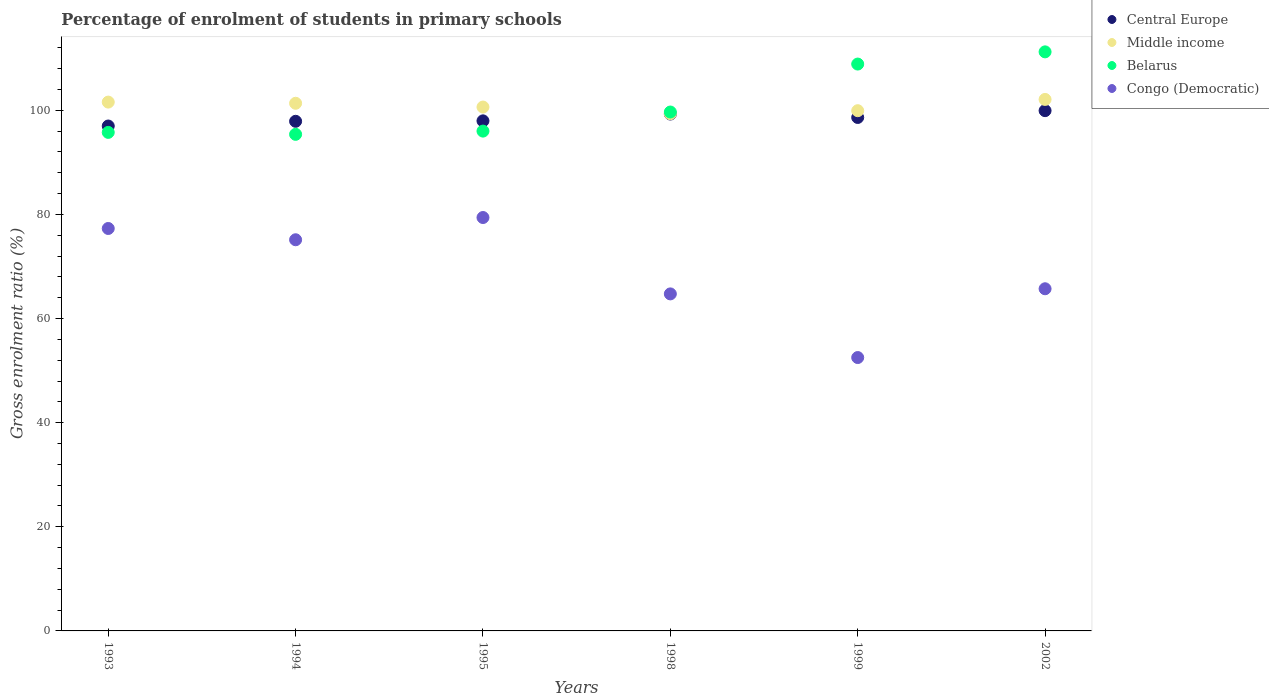Is the number of dotlines equal to the number of legend labels?
Provide a succinct answer. Yes. What is the percentage of students enrolled in primary schools in Central Europe in 1995?
Give a very brief answer. 97.98. Across all years, what is the maximum percentage of students enrolled in primary schools in Belarus?
Provide a short and direct response. 111.23. Across all years, what is the minimum percentage of students enrolled in primary schools in Middle income?
Offer a terse response. 99.35. What is the total percentage of students enrolled in primary schools in Middle income in the graph?
Keep it short and to the point. 604.95. What is the difference between the percentage of students enrolled in primary schools in Congo (Democratic) in 1993 and that in 1998?
Provide a succinct answer. 12.57. What is the difference between the percentage of students enrolled in primary schools in Central Europe in 1998 and the percentage of students enrolled in primary schools in Congo (Democratic) in 2002?
Make the answer very short. 33.56. What is the average percentage of students enrolled in primary schools in Belarus per year?
Your response must be concise. 101.16. In the year 1999, what is the difference between the percentage of students enrolled in primary schools in Belarus and percentage of students enrolled in primary schools in Congo (Democratic)?
Provide a short and direct response. 56.38. In how many years, is the percentage of students enrolled in primary schools in Congo (Democratic) greater than 52 %?
Ensure brevity in your answer.  6. What is the ratio of the percentage of students enrolled in primary schools in Congo (Democratic) in 1993 to that in 1998?
Your response must be concise. 1.19. Is the percentage of students enrolled in primary schools in Congo (Democratic) in 1999 less than that in 2002?
Give a very brief answer. Yes. Is the difference between the percentage of students enrolled in primary schools in Belarus in 1993 and 1999 greater than the difference between the percentage of students enrolled in primary schools in Congo (Democratic) in 1993 and 1999?
Offer a terse response. No. What is the difference between the highest and the second highest percentage of students enrolled in primary schools in Middle income?
Give a very brief answer. 0.51. What is the difference between the highest and the lowest percentage of students enrolled in primary schools in Belarus?
Give a very brief answer. 15.84. Is it the case that in every year, the sum of the percentage of students enrolled in primary schools in Congo (Democratic) and percentage of students enrolled in primary schools in Belarus  is greater than the percentage of students enrolled in primary schools in Central Europe?
Ensure brevity in your answer.  Yes. Does the percentage of students enrolled in primary schools in Middle income monotonically increase over the years?
Offer a very short reply. No. Is the percentage of students enrolled in primary schools in Middle income strictly greater than the percentage of students enrolled in primary schools in Central Europe over the years?
Your answer should be very brief. Yes. Is the percentage of students enrolled in primary schools in Middle income strictly less than the percentage of students enrolled in primary schools in Central Europe over the years?
Your answer should be very brief. No. How many dotlines are there?
Your answer should be very brief. 4. How many years are there in the graph?
Make the answer very short. 6. What is the difference between two consecutive major ticks on the Y-axis?
Your answer should be compact. 20. Are the values on the major ticks of Y-axis written in scientific E-notation?
Provide a short and direct response. No. Does the graph contain any zero values?
Your response must be concise. No. How many legend labels are there?
Your answer should be compact. 4. What is the title of the graph?
Provide a short and direct response. Percentage of enrolment of students in primary schools. Does "Upper middle income" appear as one of the legend labels in the graph?
Offer a very short reply. No. What is the Gross enrolment ratio (%) of Central Europe in 1993?
Your answer should be compact. 96.99. What is the Gross enrolment ratio (%) of Middle income in 1993?
Your answer should be compact. 101.58. What is the Gross enrolment ratio (%) in Belarus in 1993?
Offer a very short reply. 95.77. What is the Gross enrolment ratio (%) in Congo (Democratic) in 1993?
Provide a short and direct response. 77.31. What is the Gross enrolment ratio (%) of Central Europe in 1994?
Provide a short and direct response. 97.9. What is the Gross enrolment ratio (%) of Middle income in 1994?
Give a very brief answer. 101.36. What is the Gross enrolment ratio (%) in Belarus in 1994?
Offer a very short reply. 95.39. What is the Gross enrolment ratio (%) in Congo (Democratic) in 1994?
Provide a short and direct response. 75.14. What is the Gross enrolment ratio (%) in Central Europe in 1995?
Keep it short and to the point. 97.98. What is the Gross enrolment ratio (%) in Middle income in 1995?
Give a very brief answer. 100.63. What is the Gross enrolment ratio (%) of Belarus in 1995?
Your answer should be compact. 96.01. What is the Gross enrolment ratio (%) of Congo (Democratic) in 1995?
Offer a terse response. 79.41. What is the Gross enrolment ratio (%) in Central Europe in 1998?
Offer a terse response. 99.29. What is the Gross enrolment ratio (%) in Middle income in 1998?
Your answer should be very brief. 99.35. What is the Gross enrolment ratio (%) in Belarus in 1998?
Your response must be concise. 99.68. What is the Gross enrolment ratio (%) in Congo (Democratic) in 1998?
Your answer should be very brief. 64.74. What is the Gross enrolment ratio (%) in Central Europe in 1999?
Make the answer very short. 98.63. What is the Gross enrolment ratio (%) of Middle income in 1999?
Your answer should be very brief. 99.93. What is the Gross enrolment ratio (%) in Belarus in 1999?
Provide a short and direct response. 108.89. What is the Gross enrolment ratio (%) of Congo (Democratic) in 1999?
Your response must be concise. 52.51. What is the Gross enrolment ratio (%) in Central Europe in 2002?
Make the answer very short. 99.94. What is the Gross enrolment ratio (%) in Middle income in 2002?
Give a very brief answer. 102.1. What is the Gross enrolment ratio (%) of Belarus in 2002?
Make the answer very short. 111.23. What is the Gross enrolment ratio (%) of Congo (Democratic) in 2002?
Provide a succinct answer. 65.73. Across all years, what is the maximum Gross enrolment ratio (%) in Central Europe?
Provide a succinct answer. 99.94. Across all years, what is the maximum Gross enrolment ratio (%) of Middle income?
Ensure brevity in your answer.  102.1. Across all years, what is the maximum Gross enrolment ratio (%) of Belarus?
Provide a succinct answer. 111.23. Across all years, what is the maximum Gross enrolment ratio (%) of Congo (Democratic)?
Your answer should be very brief. 79.41. Across all years, what is the minimum Gross enrolment ratio (%) in Central Europe?
Your answer should be very brief. 96.99. Across all years, what is the minimum Gross enrolment ratio (%) of Middle income?
Your response must be concise. 99.35. Across all years, what is the minimum Gross enrolment ratio (%) in Belarus?
Provide a short and direct response. 95.39. Across all years, what is the minimum Gross enrolment ratio (%) in Congo (Democratic)?
Your answer should be very brief. 52.51. What is the total Gross enrolment ratio (%) in Central Europe in the graph?
Your answer should be very brief. 590.72. What is the total Gross enrolment ratio (%) in Middle income in the graph?
Keep it short and to the point. 604.95. What is the total Gross enrolment ratio (%) in Belarus in the graph?
Your answer should be very brief. 606.97. What is the total Gross enrolment ratio (%) in Congo (Democratic) in the graph?
Give a very brief answer. 414.83. What is the difference between the Gross enrolment ratio (%) of Central Europe in 1993 and that in 1994?
Offer a very short reply. -0.91. What is the difference between the Gross enrolment ratio (%) of Middle income in 1993 and that in 1994?
Give a very brief answer. 0.23. What is the difference between the Gross enrolment ratio (%) of Belarus in 1993 and that in 1994?
Keep it short and to the point. 0.37. What is the difference between the Gross enrolment ratio (%) in Congo (Democratic) in 1993 and that in 1994?
Make the answer very short. 2.17. What is the difference between the Gross enrolment ratio (%) in Central Europe in 1993 and that in 1995?
Provide a succinct answer. -0.99. What is the difference between the Gross enrolment ratio (%) in Middle income in 1993 and that in 1995?
Give a very brief answer. 0.95. What is the difference between the Gross enrolment ratio (%) of Belarus in 1993 and that in 1995?
Your response must be concise. -0.25. What is the difference between the Gross enrolment ratio (%) in Congo (Democratic) in 1993 and that in 1995?
Ensure brevity in your answer.  -2.11. What is the difference between the Gross enrolment ratio (%) in Central Europe in 1993 and that in 1998?
Keep it short and to the point. -2.3. What is the difference between the Gross enrolment ratio (%) in Middle income in 1993 and that in 1998?
Make the answer very short. 2.23. What is the difference between the Gross enrolment ratio (%) of Belarus in 1993 and that in 1998?
Keep it short and to the point. -3.91. What is the difference between the Gross enrolment ratio (%) of Congo (Democratic) in 1993 and that in 1998?
Make the answer very short. 12.57. What is the difference between the Gross enrolment ratio (%) in Central Europe in 1993 and that in 1999?
Your response must be concise. -1.64. What is the difference between the Gross enrolment ratio (%) in Middle income in 1993 and that in 1999?
Your answer should be compact. 1.65. What is the difference between the Gross enrolment ratio (%) in Belarus in 1993 and that in 1999?
Offer a terse response. -13.12. What is the difference between the Gross enrolment ratio (%) in Congo (Democratic) in 1993 and that in 1999?
Your response must be concise. 24.79. What is the difference between the Gross enrolment ratio (%) in Central Europe in 1993 and that in 2002?
Your answer should be compact. -2.95. What is the difference between the Gross enrolment ratio (%) in Middle income in 1993 and that in 2002?
Provide a succinct answer. -0.51. What is the difference between the Gross enrolment ratio (%) of Belarus in 1993 and that in 2002?
Your response must be concise. -15.47. What is the difference between the Gross enrolment ratio (%) of Congo (Democratic) in 1993 and that in 2002?
Provide a short and direct response. 11.58. What is the difference between the Gross enrolment ratio (%) in Central Europe in 1994 and that in 1995?
Provide a succinct answer. -0.09. What is the difference between the Gross enrolment ratio (%) in Middle income in 1994 and that in 1995?
Your response must be concise. 0.72. What is the difference between the Gross enrolment ratio (%) of Belarus in 1994 and that in 1995?
Keep it short and to the point. -0.62. What is the difference between the Gross enrolment ratio (%) of Congo (Democratic) in 1994 and that in 1995?
Ensure brevity in your answer.  -4.27. What is the difference between the Gross enrolment ratio (%) in Central Europe in 1994 and that in 1998?
Provide a short and direct response. -1.39. What is the difference between the Gross enrolment ratio (%) in Middle income in 1994 and that in 1998?
Keep it short and to the point. 2. What is the difference between the Gross enrolment ratio (%) of Belarus in 1994 and that in 1998?
Give a very brief answer. -4.29. What is the difference between the Gross enrolment ratio (%) in Congo (Democratic) in 1994 and that in 1998?
Give a very brief answer. 10.4. What is the difference between the Gross enrolment ratio (%) in Central Europe in 1994 and that in 1999?
Provide a short and direct response. -0.74. What is the difference between the Gross enrolment ratio (%) of Middle income in 1994 and that in 1999?
Your answer should be very brief. 1.42. What is the difference between the Gross enrolment ratio (%) in Belarus in 1994 and that in 1999?
Ensure brevity in your answer.  -13.5. What is the difference between the Gross enrolment ratio (%) of Congo (Democratic) in 1994 and that in 1999?
Offer a terse response. 22.63. What is the difference between the Gross enrolment ratio (%) of Central Europe in 1994 and that in 2002?
Offer a terse response. -2.05. What is the difference between the Gross enrolment ratio (%) in Middle income in 1994 and that in 2002?
Keep it short and to the point. -0.74. What is the difference between the Gross enrolment ratio (%) in Belarus in 1994 and that in 2002?
Ensure brevity in your answer.  -15.84. What is the difference between the Gross enrolment ratio (%) of Congo (Democratic) in 1994 and that in 2002?
Offer a very short reply. 9.41. What is the difference between the Gross enrolment ratio (%) of Central Europe in 1995 and that in 1998?
Provide a short and direct response. -1.31. What is the difference between the Gross enrolment ratio (%) of Middle income in 1995 and that in 1998?
Make the answer very short. 1.28. What is the difference between the Gross enrolment ratio (%) of Belarus in 1995 and that in 1998?
Your answer should be very brief. -3.67. What is the difference between the Gross enrolment ratio (%) in Congo (Democratic) in 1995 and that in 1998?
Make the answer very short. 14.67. What is the difference between the Gross enrolment ratio (%) of Central Europe in 1995 and that in 1999?
Give a very brief answer. -0.65. What is the difference between the Gross enrolment ratio (%) in Middle income in 1995 and that in 1999?
Your answer should be very brief. 0.7. What is the difference between the Gross enrolment ratio (%) of Belarus in 1995 and that in 1999?
Provide a short and direct response. -12.88. What is the difference between the Gross enrolment ratio (%) of Congo (Democratic) in 1995 and that in 1999?
Provide a short and direct response. 26.9. What is the difference between the Gross enrolment ratio (%) in Central Europe in 1995 and that in 2002?
Your answer should be compact. -1.96. What is the difference between the Gross enrolment ratio (%) of Middle income in 1995 and that in 2002?
Offer a terse response. -1.46. What is the difference between the Gross enrolment ratio (%) in Belarus in 1995 and that in 2002?
Your answer should be compact. -15.22. What is the difference between the Gross enrolment ratio (%) in Congo (Democratic) in 1995 and that in 2002?
Make the answer very short. 13.68. What is the difference between the Gross enrolment ratio (%) of Central Europe in 1998 and that in 1999?
Your answer should be compact. 0.66. What is the difference between the Gross enrolment ratio (%) in Middle income in 1998 and that in 1999?
Offer a terse response. -0.58. What is the difference between the Gross enrolment ratio (%) in Belarus in 1998 and that in 1999?
Make the answer very short. -9.21. What is the difference between the Gross enrolment ratio (%) in Congo (Democratic) in 1998 and that in 1999?
Your response must be concise. 12.23. What is the difference between the Gross enrolment ratio (%) in Central Europe in 1998 and that in 2002?
Offer a terse response. -0.65. What is the difference between the Gross enrolment ratio (%) of Middle income in 1998 and that in 2002?
Make the answer very short. -2.74. What is the difference between the Gross enrolment ratio (%) of Belarus in 1998 and that in 2002?
Keep it short and to the point. -11.56. What is the difference between the Gross enrolment ratio (%) in Congo (Democratic) in 1998 and that in 2002?
Give a very brief answer. -0.99. What is the difference between the Gross enrolment ratio (%) of Central Europe in 1999 and that in 2002?
Make the answer very short. -1.31. What is the difference between the Gross enrolment ratio (%) in Middle income in 1999 and that in 2002?
Provide a succinct answer. -2.16. What is the difference between the Gross enrolment ratio (%) in Belarus in 1999 and that in 2002?
Your answer should be very brief. -2.34. What is the difference between the Gross enrolment ratio (%) in Congo (Democratic) in 1999 and that in 2002?
Offer a terse response. -13.21. What is the difference between the Gross enrolment ratio (%) in Central Europe in 1993 and the Gross enrolment ratio (%) in Middle income in 1994?
Your answer should be very brief. -4.37. What is the difference between the Gross enrolment ratio (%) in Central Europe in 1993 and the Gross enrolment ratio (%) in Belarus in 1994?
Give a very brief answer. 1.6. What is the difference between the Gross enrolment ratio (%) in Central Europe in 1993 and the Gross enrolment ratio (%) in Congo (Democratic) in 1994?
Keep it short and to the point. 21.85. What is the difference between the Gross enrolment ratio (%) of Middle income in 1993 and the Gross enrolment ratio (%) of Belarus in 1994?
Offer a very short reply. 6.19. What is the difference between the Gross enrolment ratio (%) of Middle income in 1993 and the Gross enrolment ratio (%) of Congo (Democratic) in 1994?
Give a very brief answer. 26.44. What is the difference between the Gross enrolment ratio (%) in Belarus in 1993 and the Gross enrolment ratio (%) in Congo (Democratic) in 1994?
Your answer should be compact. 20.63. What is the difference between the Gross enrolment ratio (%) in Central Europe in 1993 and the Gross enrolment ratio (%) in Middle income in 1995?
Offer a terse response. -3.64. What is the difference between the Gross enrolment ratio (%) of Central Europe in 1993 and the Gross enrolment ratio (%) of Belarus in 1995?
Provide a succinct answer. 0.98. What is the difference between the Gross enrolment ratio (%) of Central Europe in 1993 and the Gross enrolment ratio (%) of Congo (Democratic) in 1995?
Give a very brief answer. 17.58. What is the difference between the Gross enrolment ratio (%) of Middle income in 1993 and the Gross enrolment ratio (%) of Belarus in 1995?
Provide a short and direct response. 5.57. What is the difference between the Gross enrolment ratio (%) in Middle income in 1993 and the Gross enrolment ratio (%) in Congo (Democratic) in 1995?
Offer a terse response. 22.17. What is the difference between the Gross enrolment ratio (%) in Belarus in 1993 and the Gross enrolment ratio (%) in Congo (Democratic) in 1995?
Offer a terse response. 16.35. What is the difference between the Gross enrolment ratio (%) of Central Europe in 1993 and the Gross enrolment ratio (%) of Middle income in 1998?
Make the answer very short. -2.36. What is the difference between the Gross enrolment ratio (%) of Central Europe in 1993 and the Gross enrolment ratio (%) of Belarus in 1998?
Provide a succinct answer. -2.69. What is the difference between the Gross enrolment ratio (%) in Central Europe in 1993 and the Gross enrolment ratio (%) in Congo (Democratic) in 1998?
Your response must be concise. 32.25. What is the difference between the Gross enrolment ratio (%) in Middle income in 1993 and the Gross enrolment ratio (%) in Belarus in 1998?
Provide a short and direct response. 1.91. What is the difference between the Gross enrolment ratio (%) of Middle income in 1993 and the Gross enrolment ratio (%) of Congo (Democratic) in 1998?
Your response must be concise. 36.84. What is the difference between the Gross enrolment ratio (%) in Belarus in 1993 and the Gross enrolment ratio (%) in Congo (Democratic) in 1998?
Your answer should be very brief. 31.03. What is the difference between the Gross enrolment ratio (%) in Central Europe in 1993 and the Gross enrolment ratio (%) in Middle income in 1999?
Offer a very short reply. -2.94. What is the difference between the Gross enrolment ratio (%) of Central Europe in 1993 and the Gross enrolment ratio (%) of Belarus in 1999?
Provide a short and direct response. -11.9. What is the difference between the Gross enrolment ratio (%) in Central Europe in 1993 and the Gross enrolment ratio (%) in Congo (Democratic) in 1999?
Provide a short and direct response. 44.47. What is the difference between the Gross enrolment ratio (%) of Middle income in 1993 and the Gross enrolment ratio (%) of Belarus in 1999?
Offer a very short reply. -7.31. What is the difference between the Gross enrolment ratio (%) in Middle income in 1993 and the Gross enrolment ratio (%) in Congo (Democratic) in 1999?
Your answer should be compact. 49.07. What is the difference between the Gross enrolment ratio (%) in Belarus in 1993 and the Gross enrolment ratio (%) in Congo (Democratic) in 1999?
Offer a very short reply. 43.25. What is the difference between the Gross enrolment ratio (%) in Central Europe in 1993 and the Gross enrolment ratio (%) in Middle income in 2002?
Offer a very short reply. -5.11. What is the difference between the Gross enrolment ratio (%) in Central Europe in 1993 and the Gross enrolment ratio (%) in Belarus in 2002?
Offer a very short reply. -14.25. What is the difference between the Gross enrolment ratio (%) of Central Europe in 1993 and the Gross enrolment ratio (%) of Congo (Democratic) in 2002?
Your answer should be very brief. 31.26. What is the difference between the Gross enrolment ratio (%) in Middle income in 1993 and the Gross enrolment ratio (%) in Belarus in 2002?
Offer a very short reply. -9.65. What is the difference between the Gross enrolment ratio (%) of Middle income in 1993 and the Gross enrolment ratio (%) of Congo (Democratic) in 2002?
Ensure brevity in your answer.  35.86. What is the difference between the Gross enrolment ratio (%) in Belarus in 1993 and the Gross enrolment ratio (%) in Congo (Democratic) in 2002?
Provide a succinct answer. 30.04. What is the difference between the Gross enrolment ratio (%) of Central Europe in 1994 and the Gross enrolment ratio (%) of Middle income in 1995?
Offer a terse response. -2.74. What is the difference between the Gross enrolment ratio (%) of Central Europe in 1994 and the Gross enrolment ratio (%) of Belarus in 1995?
Your answer should be very brief. 1.88. What is the difference between the Gross enrolment ratio (%) in Central Europe in 1994 and the Gross enrolment ratio (%) in Congo (Democratic) in 1995?
Provide a short and direct response. 18.48. What is the difference between the Gross enrolment ratio (%) of Middle income in 1994 and the Gross enrolment ratio (%) of Belarus in 1995?
Provide a short and direct response. 5.34. What is the difference between the Gross enrolment ratio (%) in Middle income in 1994 and the Gross enrolment ratio (%) in Congo (Democratic) in 1995?
Your answer should be very brief. 21.95. What is the difference between the Gross enrolment ratio (%) in Belarus in 1994 and the Gross enrolment ratio (%) in Congo (Democratic) in 1995?
Keep it short and to the point. 15.98. What is the difference between the Gross enrolment ratio (%) of Central Europe in 1994 and the Gross enrolment ratio (%) of Middle income in 1998?
Ensure brevity in your answer.  -1.46. What is the difference between the Gross enrolment ratio (%) of Central Europe in 1994 and the Gross enrolment ratio (%) of Belarus in 1998?
Keep it short and to the point. -1.78. What is the difference between the Gross enrolment ratio (%) of Central Europe in 1994 and the Gross enrolment ratio (%) of Congo (Democratic) in 1998?
Your response must be concise. 33.16. What is the difference between the Gross enrolment ratio (%) of Middle income in 1994 and the Gross enrolment ratio (%) of Belarus in 1998?
Your answer should be compact. 1.68. What is the difference between the Gross enrolment ratio (%) of Middle income in 1994 and the Gross enrolment ratio (%) of Congo (Democratic) in 1998?
Keep it short and to the point. 36.62. What is the difference between the Gross enrolment ratio (%) of Belarus in 1994 and the Gross enrolment ratio (%) of Congo (Democratic) in 1998?
Offer a terse response. 30.65. What is the difference between the Gross enrolment ratio (%) of Central Europe in 1994 and the Gross enrolment ratio (%) of Middle income in 1999?
Give a very brief answer. -2.04. What is the difference between the Gross enrolment ratio (%) in Central Europe in 1994 and the Gross enrolment ratio (%) in Belarus in 1999?
Offer a very short reply. -10.99. What is the difference between the Gross enrolment ratio (%) in Central Europe in 1994 and the Gross enrolment ratio (%) in Congo (Democratic) in 1999?
Make the answer very short. 45.38. What is the difference between the Gross enrolment ratio (%) of Middle income in 1994 and the Gross enrolment ratio (%) of Belarus in 1999?
Provide a short and direct response. -7.53. What is the difference between the Gross enrolment ratio (%) of Middle income in 1994 and the Gross enrolment ratio (%) of Congo (Democratic) in 1999?
Provide a succinct answer. 48.84. What is the difference between the Gross enrolment ratio (%) of Belarus in 1994 and the Gross enrolment ratio (%) of Congo (Democratic) in 1999?
Your response must be concise. 42.88. What is the difference between the Gross enrolment ratio (%) of Central Europe in 1994 and the Gross enrolment ratio (%) of Middle income in 2002?
Your answer should be very brief. -4.2. What is the difference between the Gross enrolment ratio (%) of Central Europe in 1994 and the Gross enrolment ratio (%) of Belarus in 2002?
Make the answer very short. -13.34. What is the difference between the Gross enrolment ratio (%) of Central Europe in 1994 and the Gross enrolment ratio (%) of Congo (Democratic) in 2002?
Provide a short and direct response. 32.17. What is the difference between the Gross enrolment ratio (%) of Middle income in 1994 and the Gross enrolment ratio (%) of Belarus in 2002?
Provide a short and direct response. -9.88. What is the difference between the Gross enrolment ratio (%) in Middle income in 1994 and the Gross enrolment ratio (%) in Congo (Democratic) in 2002?
Make the answer very short. 35.63. What is the difference between the Gross enrolment ratio (%) in Belarus in 1994 and the Gross enrolment ratio (%) in Congo (Democratic) in 2002?
Your answer should be compact. 29.67. What is the difference between the Gross enrolment ratio (%) of Central Europe in 1995 and the Gross enrolment ratio (%) of Middle income in 1998?
Your response must be concise. -1.37. What is the difference between the Gross enrolment ratio (%) of Central Europe in 1995 and the Gross enrolment ratio (%) of Belarus in 1998?
Offer a very short reply. -1.7. What is the difference between the Gross enrolment ratio (%) in Central Europe in 1995 and the Gross enrolment ratio (%) in Congo (Democratic) in 1998?
Your response must be concise. 33.24. What is the difference between the Gross enrolment ratio (%) of Middle income in 1995 and the Gross enrolment ratio (%) of Belarus in 1998?
Give a very brief answer. 0.95. What is the difference between the Gross enrolment ratio (%) in Middle income in 1995 and the Gross enrolment ratio (%) in Congo (Democratic) in 1998?
Ensure brevity in your answer.  35.89. What is the difference between the Gross enrolment ratio (%) of Belarus in 1995 and the Gross enrolment ratio (%) of Congo (Democratic) in 1998?
Offer a terse response. 31.27. What is the difference between the Gross enrolment ratio (%) of Central Europe in 1995 and the Gross enrolment ratio (%) of Middle income in 1999?
Your answer should be compact. -1.95. What is the difference between the Gross enrolment ratio (%) of Central Europe in 1995 and the Gross enrolment ratio (%) of Belarus in 1999?
Offer a terse response. -10.91. What is the difference between the Gross enrolment ratio (%) in Central Europe in 1995 and the Gross enrolment ratio (%) in Congo (Democratic) in 1999?
Your response must be concise. 45.47. What is the difference between the Gross enrolment ratio (%) of Middle income in 1995 and the Gross enrolment ratio (%) of Belarus in 1999?
Offer a terse response. -8.26. What is the difference between the Gross enrolment ratio (%) of Middle income in 1995 and the Gross enrolment ratio (%) of Congo (Democratic) in 1999?
Offer a terse response. 48.12. What is the difference between the Gross enrolment ratio (%) of Belarus in 1995 and the Gross enrolment ratio (%) of Congo (Democratic) in 1999?
Offer a very short reply. 43.5. What is the difference between the Gross enrolment ratio (%) in Central Europe in 1995 and the Gross enrolment ratio (%) in Middle income in 2002?
Ensure brevity in your answer.  -4.12. What is the difference between the Gross enrolment ratio (%) in Central Europe in 1995 and the Gross enrolment ratio (%) in Belarus in 2002?
Offer a terse response. -13.25. What is the difference between the Gross enrolment ratio (%) in Central Europe in 1995 and the Gross enrolment ratio (%) in Congo (Democratic) in 2002?
Provide a succinct answer. 32.25. What is the difference between the Gross enrolment ratio (%) in Middle income in 1995 and the Gross enrolment ratio (%) in Belarus in 2002?
Ensure brevity in your answer.  -10.6. What is the difference between the Gross enrolment ratio (%) of Middle income in 1995 and the Gross enrolment ratio (%) of Congo (Democratic) in 2002?
Provide a short and direct response. 34.91. What is the difference between the Gross enrolment ratio (%) of Belarus in 1995 and the Gross enrolment ratio (%) of Congo (Democratic) in 2002?
Give a very brief answer. 30.29. What is the difference between the Gross enrolment ratio (%) in Central Europe in 1998 and the Gross enrolment ratio (%) in Middle income in 1999?
Provide a short and direct response. -0.64. What is the difference between the Gross enrolment ratio (%) in Central Europe in 1998 and the Gross enrolment ratio (%) in Belarus in 1999?
Ensure brevity in your answer.  -9.6. What is the difference between the Gross enrolment ratio (%) of Central Europe in 1998 and the Gross enrolment ratio (%) of Congo (Democratic) in 1999?
Provide a succinct answer. 46.78. What is the difference between the Gross enrolment ratio (%) of Middle income in 1998 and the Gross enrolment ratio (%) of Belarus in 1999?
Ensure brevity in your answer.  -9.54. What is the difference between the Gross enrolment ratio (%) in Middle income in 1998 and the Gross enrolment ratio (%) in Congo (Democratic) in 1999?
Offer a terse response. 46.84. What is the difference between the Gross enrolment ratio (%) of Belarus in 1998 and the Gross enrolment ratio (%) of Congo (Democratic) in 1999?
Offer a very short reply. 47.16. What is the difference between the Gross enrolment ratio (%) in Central Europe in 1998 and the Gross enrolment ratio (%) in Middle income in 2002?
Your response must be concise. -2.81. What is the difference between the Gross enrolment ratio (%) of Central Europe in 1998 and the Gross enrolment ratio (%) of Belarus in 2002?
Offer a very short reply. -11.95. What is the difference between the Gross enrolment ratio (%) of Central Europe in 1998 and the Gross enrolment ratio (%) of Congo (Democratic) in 2002?
Make the answer very short. 33.56. What is the difference between the Gross enrolment ratio (%) of Middle income in 1998 and the Gross enrolment ratio (%) of Belarus in 2002?
Give a very brief answer. -11.88. What is the difference between the Gross enrolment ratio (%) of Middle income in 1998 and the Gross enrolment ratio (%) of Congo (Democratic) in 2002?
Provide a succinct answer. 33.63. What is the difference between the Gross enrolment ratio (%) of Belarus in 1998 and the Gross enrolment ratio (%) of Congo (Democratic) in 2002?
Keep it short and to the point. 33.95. What is the difference between the Gross enrolment ratio (%) in Central Europe in 1999 and the Gross enrolment ratio (%) in Middle income in 2002?
Provide a succinct answer. -3.46. What is the difference between the Gross enrolment ratio (%) of Central Europe in 1999 and the Gross enrolment ratio (%) of Belarus in 2002?
Provide a succinct answer. -12.6. What is the difference between the Gross enrolment ratio (%) in Central Europe in 1999 and the Gross enrolment ratio (%) in Congo (Democratic) in 2002?
Give a very brief answer. 32.91. What is the difference between the Gross enrolment ratio (%) in Middle income in 1999 and the Gross enrolment ratio (%) in Belarus in 2002?
Make the answer very short. -11.3. What is the difference between the Gross enrolment ratio (%) in Middle income in 1999 and the Gross enrolment ratio (%) in Congo (Democratic) in 2002?
Provide a succinct answer. 34.21. What is the difference between the Gross enrolment ratio (%) of Belarus in 1999 and the Gross enrolment ratio (%) of Congo (Democratic) in 2002?
Keep it short and to the point. 43.16. What is the average Gross enrolment ratio (%) in Central Europe per year?
Ensure brevity in your answer.  98.45. What is the average Gross enrolment ratio (%) of Middle income per year?
Ensure brevity in your answer.  100.83. What is the average Gross enrolment ratio (%) of Belarus per year?
Ensure brevity in your answer.  101.16. What is the average Gross enrolment ratio (%) of Congo (Democratic) per year?
Provide a short and direct response. 69.14. In the year 1993, what is the difference between the Gross enrolment ratio (%) of Central Europe and Gross enrolment ratio (%) of Middle income?
Ensure brevity in your answer.  -4.6. In the year 1993, what is the difference between the Gross enrolment ratio (%) of Central Europe and Gross enrolment ratio (%) of Belarus?
Your answer should be compact. 1.22. In the year 1993, what is the difference between the Gross enrolment ratio (%) of Central Europe and Gross enrolment ratio (%) of Congo (Democratic)?
Make the answer very short. 19.68. In the year 1993, what is the difference between the Gross enrolment ratio (%) in Middle income and Gross enrolment ratio (%) in Belarus?
Your answer should be compact. 5.82. In the year 1993, what is the difference between the Gross enrolment ratio (%) in Middle income and Gross enrolment ratio (%) in Congo (Democratic)?
Your answer should be compact. 24.28. In the year 1993, what is the difference between the Gross enrolment ratio (%) in Belarus and Gross enrolment ratio (%) in Congo (Democratic)?
Your answer should be very brief. 18.46. In the year 1994, what is the difference between the Gross enrolment ratio (%) of Central Europe and Gross enrolment ratio (%) of Middle income?
Give a very brief answer. -3.46. In the year 1994, what is the difference between the Gross enrolment ratio (%) in Central Europe and Gross enrolment ratio (%) in Belarus?
Keep it short and to the point. 2.5. In the year 1994, what is the difference between the Gross enrolment ratio (%) of Central Europe and Gross enrolment ratio (%) of Congo (Democratic)?
Your response must be concise. 22.76. In the year 1994, what is the difference between the Gross enrolment ratio (%) in Middle income and Gross enrolment ratio (%) in Belarus?
Ensure brevity in your answer.  5.97. In the year 1994, what is the difference between the Gross enrolment ratio (%) in Middle income and Gross enrolment ratio (%) in Congo (Democratic)?
Make the answer very short. 26.22. In the year 1994, what is the difference between the Gross enrolment ratio (%) of Belarus and Gross enrolment ratio (%) of Congo (Democratic)?
Your response must be concise. 20.25. In the year 1995, what is the difference between the Gross enrolment ratio (%) in Central Europe and Gross enrolment ratio (%) in Middle income?
Your response must be concise. -2.65. In the year 1995, what is the difference between the Gross enrolment ratio (%) of Central Europe and Gross enrolment ratio (%) of Belarus?
Ensure brevity in your answer.  1.97. In the year 1995, what is the difference between the Gross enrolment ratio (%) of Central Europe and Gross enrolment ratio (%) of Congo (Democratic)?
Offer a very short reply. 18.57. In the year 1995, what is the difference between the Gross enrolment ratio (%) in Middle income and Gross enrolment ratio (%) in Belarus?
Ensure brevity in your answer.  4.62. In the year 1995, what is the difference between the Gross enrolment ratio (%) in Middle income and Gross enrolment ratio (%) in Congo (Democratic)?
Give a very brief answer. 21.22. In the year 1995, what is the difference between the Gross enrolment ratio (%) in Belarus and Gross enrolment ratio (%) in Congo (Democratic)?
Give a very brief answer. 16.6. In the year 1998, what is the difference between the Gross enrolment ratio (%) of Central Europe and Gross enrolment ratio (%) of Middle income?
Give a very brief answer. -0.06. In the year 1998, what is the difference between the Gross enrolment ratio (%) in Central Europe and Gross enrolment ratio (%) in Belarus?
Ensure brevity in your answer.  -0.39. In the year 1998, what is the difference between the Gross enrolment ratio (%) in Central Europe and Gross enrolment ratio (%) in Congo (Democratic)?
Provide a short and direct response. 34.55. In the year 1998, what is the difference between the Gross enrolment ratio (%) in Middle income and Gross enrolment ratio (%) in Belarus?
Your response must be concise. -0.33. In the year 1998, what is the difference between the Gross enrolment ratio (%) in Middle income and Gross enrolment ratio (%) in Congo (Democratic)?
Your answer should be compact. 34.61. In the year 1998, what is the difference between the Gross enrolment ratio (%) of Belarus and Gross enrolment ratio (%) of Congo (Democratic)?
Your response must be concise. 34.94. In the year 1999, what is the difference between the Gross enrolment ratio (%) in Central Europe and Gross enrolment ratio (%) in Middle income?
Offer a very short reply. -1.3. In the year 1999, what is the difference between the Gross enrolment ratio (%) in Central Europe and Gross enrolment ratio (%) in Belarus?
Your answer should be compact. -10.26. In the year 1999, what is the difference between the Gross enrolment ratio (%) of Central Europe and Gross enrolment ratio (%) of Congo (Democratic)?
Your response must be concise. 46.12. In the year 1999, what is the difference between the Gross enrolment ratio (%) of Middle income and Gross enrolment ratio (%) of Belarus?
Keep it short and to the point. -8.96. In the year 1999, what is the difference between the Gross enrolment ratio (%) of Middle income and Gross enrolment ratio (%) of Congo (Democratic)?
Your answer should be very brief. 47.42. In the year 1999, what is the difference between the Gross enrolment ratio (%) of Belarus and Gross enrolment ratio (%) of Congo (Democratic)?
Offer a very short reply. 56.38. In the year 2002, what is the difference between the Gross enrolment ratio (%) in Central Europe and Gross enrolment ratio (%) in Middle income?
Your answer should be very brief. -2.16. In the year 2002, what is the difference between the Gross enrolment ratio (%) in Central Europe and Gross enrolment ratio (%) in Belarus?
Your response must be concise. -11.29. In the year 2002, what is the difference between the Gross enrolment ratio (%) in Central Europe and Gross enrolment ratio (%) in Congo (Democratic)?
Your response must be concise. 34.21. In the year 2002, what is the difference between the Gross enrolment ratio (%) of Middle income and Gross enrolment ratio (%) of Belarus?
Make the answer very short. -9.14. In the year 2002, what is the difference between the Gross enrolment ratio (%) in Middle income and Gross enrolment ratio (%) in Congo (Democratic)?
Make the answer very short. 36.37. In the year 2002, what is the difference between the Gross enrolment ratio (%) of Belarus and Gross enrolment ratio (%) of Congo (Democratic)?
Give a very brief answer. 45.51. What is the ratio of the Gross enrolment ratio (%) in Central Europe in 1993 to that in 1994?
Give a very brief answer. 0.99. What is the ratio of the Gross enrolment ratio (%) in Middle income in 1993 to that in 1994?
Offer a terse response. 1. What is the ratio of the Gross enrolment ratio (%) in Congo (Democratic) in 1993 to that in 1994?
Give a very brief answer. 1.03. What is the ratio of the Gross enrolment ratio (%) in Central Europe in 1993 to that in 1995?
Provide a short and direct response. 0.99. What is the ratio of the Gross enrolment ratio (%) of Middle income in 1993 to that in 1995?
Offer a very short reply. 1.01. What is the ratio of the Gross enrolment ratio (%) of Belarus in 1993 to that in 1995?
Keep it short and to the point. 1. What is the ratio of the Gross enrolment ratio (%) of Congo (Democratic) in 1993 to that in 1995?
Provide a short and direct response. 0.97. What is the ratio of the Gross enrolment ratio (%) of Central Europe in 1993 to that in 1998?
Offer a terse response. 0.98. What is the ratio of the Gross enrolment ratio (%) of Middle income in 1993 to that in 1998?
Offer a terse response. 1.02. What is the ratio of the Gross enrolment ratio (%) of Belarus in 1993 to that in 1998?
Make the answer very short. 0.96. What is the ratio of the Gross enrolment ratio (%) in Congo (Democratic) in 1993 to that in 1998?
Give a very brief answer. 1.19. What is the ratio of the Gross enrolment ratio (%) of Central Europe in 1993 to that in 1999?
Offer a terse response. 0.98. What is the ratio of the Gross enrolment ratio (%) in Middle income in 1993 to that in 1999?
Offer a very short reply. 1.02. What is the ratio of the Gross enrolment ratio (%) in Belarus in 1993 to that in 1999?
Make the answer very short. 0.88. What is the ratio of the Gross enrolment ratio (%) in Congo (Democratic) in 1993 to that in 1999?
Provide a short and direct response. 1.47. What is the ratio of the Gross enrolment ratio (%) of Central Europe in 1993 to that in 2002?
Keep it short and to the point. 0.97. What is the ratio of the Gross enrolment ratio (%) of Belarus in 1993 to that in 2002?
Your answer should be compact. 0.86. What is the ratio of the Gross enrolment ratio (%) in Congo (Democratic) in 1993 to that in 2002?
Ensure brevity in your answer.  1.18. What is the ratio of the Gross enrolment ratio (%) of Central Europe in 1994 to that in 1995?
Ensure brevity in your answer.  1. What is the ratio of the Gross enrolment ratio (%) of Belarus in 1994 to that in 1995?
Keep it short and to the point. 0.99. What is the ratio of the Gross enrolment ratio (%) of Congo (Democratic) in 1994 to that in 1995?
Provide a short and direct response. 0.95. What is the ratio of the Gross enrolment ratio (%) of Central Europe in 1994 to that in 1998?
Your answer should be compact. 0.99. What is the ratio of the Gross enrolment ratio (%) of Middle income in 1994 to that in 1998?
Keep it short and to the point. 1.02. What is the ratio of the Gross enrolment ratio (%) in Congo (Democratic) in 1994 to that in 1998?
Offer a terse response. 1.16. What is the ratio of the Gross enrolment ratio (%) in Central Europe in 1994 to that in 1999?
Your response must be concise. 0.99. What is the ratio of the Gross enrolment ratio (%) in Middle income in 1994 to that in 1999?
Give a very brief answer. 1.01. What is the ratio of the Gross enrolment ratio (%) of Belarus in 1994 to that in 1999?
Give a very brief answer. 0.88. What is the ratio of the Gross enrolment ratio (%) of Congo (Democratic) in 1994 to that in 1999?
Your answer should be very brief. 1.43. What is the ratio of the Gross enrolment ratio (%) in Central Europe in 1994 to that in 2002?
Offer a terse response. 0.98. What is the ratio of the Gross enrolment ratio (%) of Middle income in 1994 to that in 2002?
Ensure brevity in your answer.  0.99. What is the ratio of the Gross enrolment ratio (%) of Belarus in 1994 to that in 2002?
Your answer should be compact. 0.86. What is the ratio of the Gross enrolment ratio (%) of Congo (Democratic) in 1994 to that in 2002?
Ensure brevity in your answer.  1.14. What is the ratio of the Gross enrolment ratio (%) of Middle income in 1995 to that in 1998?
Ensure brevity in your answer.  1.01. What is the ratio of the Gross enrolment ratio (%) in Belarus in 1995 to that in 1998?
Your answer should be very brief. 0.96. What is the ratio of the Gross enrolment ratio (%) in Congo (Democratic) in 1995 to that in 1998?
Make the answer very short. 1.23. What is the ratio of the Gross enrolment ratio (%) of Central Europe in 1995 to that in 1999?
Ensure brevity in your answer.  0.99. What is the ratio of the Gross enrolment ratio (%) of Middle income in 1995 to that in 1999?
Your answer should be very brief. 1.01. What is the ratio of the Gross enrolment ratio (%) in Belarus in 1995 to that in 1999?
Give a very brief answer. 0.88. What is the ratio of the Gross enrolment ratio (%) in Congo (Democratic) in 1995 to that in 1999?
Offer a very short reply. 1.51. What is the ratio of the Gross enrolment ratio (%) of Central Europe in 1995 to that in 2002?
Your response must be concise. 0.98. What is the ratio of the Gross enrolment ratio (%) of Middle income in 1995 to that in 2002?
Your answer should be very brief. 0.99. What is the ratio of the Gross enrolment ratio (%) in Belarus in 1995 to that in 2002?
Your answer should be compact. 0.86. What is the ratio of the Gross enrolment ratio (%) of Congo (Democratic) in 1995 to that in 2002?
Offer a terse response. 1.21. What is the ratio of the Gross enrolment ratio (%) of Middle income in 1998 to that in 1999?
Your answer should be compact. 0.99. What is the ratio of the Gross enrolment ratio (%) in Belarus in 1998 to that in 1999?
Make the answer very short. 0.92. What is the ratio of the Gross enrolment ratio (%) in Congo (Democratic) in 1998 to that in 1999?
Give a very brief answer. 1.23. What is the ratio of the Gross enrolment ratio (%) in Central Europe in 1998 to that in 2002?
Provide a short and direct response. 0.99. What is the ratio of the Gross enrolment ratio (%) in Middle income in 1998 to that in 2002?
Make the answer very short. 0.97. What is the ratio of the Gross enrolment ratio (%) in Belarus in 1998 to that in 2002?
Your response must be concise. 0.9. What is the ratio of the Gross enrolment ratio (%) of Central Europe in 1999 to that in 2002?
Keep it short and to the point. 0.99. What is the ratio of the Gross enrolment ratio (%) in Middle income in 1999 to that in 2002?
Provide a short and direct response. 0.98. What is the ratio of the Gross enrolment ratio (%) in Belarus in 1999 to that in 2002?
Provide a succinct answer. 0.98. What is the ratio of the Gross enrolment ratio (%) in Congo (Democratic) in 1999 to that in 2002?
Provide a short and direct response. 0.8. What is the difference between the highest and the second highest Gross enrolment ratio (%) of Central Europe?
Provide a short and direct response. 0.65. What is the difference between the highest and the second highest Gross enrolment ratio (%) in Middle income?
Provide a succinct answer. 0.51. What is the difference between the highest and the second highest Gross enrolment ratio (%) of Belarus?
Give a very brief answer. 2.34. What is the difference between the highest and the second highest Gross enrolment ratio (%) of Congo (Democratic)?
Offer a very short reply. 2.11. What is the difference between the highest and the lowest Gross enrolment ratio (%) of Central Europe?
Provide a succinct answer. 2.95. What is the difference between the highest and the lowest Gross enrolment ratio (%) of Middle income?
Your answer should be very brief. 2.74. What is the difference between the highest and the lowest Gross enrolment ratio (%) of Belarus?
Offer a very short reply. 15.84. What is the difference between the highest and the lowest Gross enrolment ratio (%) in Congo (Democratic)?
Keep it short and to the point. 26.9. 